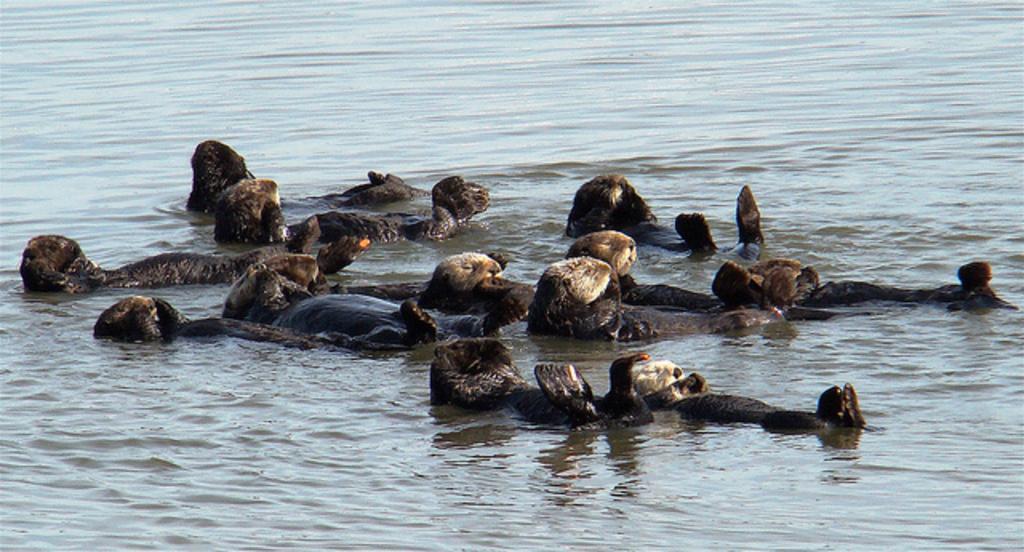Please provide a concise description of this image. This picture shows few animals in the water. 